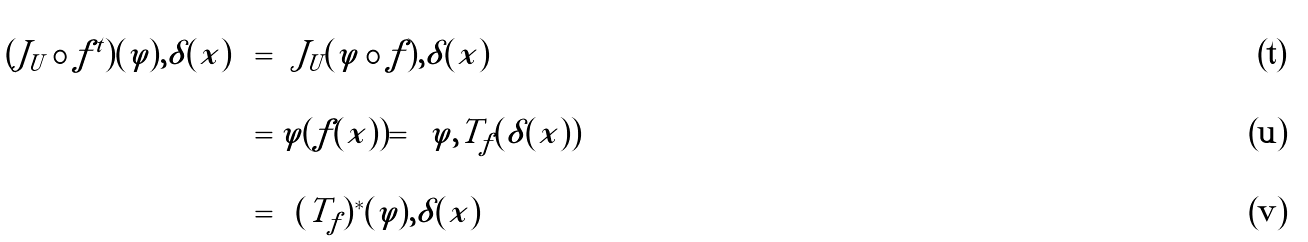Convert formula to latex. <formula><loc_0><loc_0><loc_500><loc_500>\left \langle ( J _ { U } \circ f ^ { t } ) ( \varphi ) , \delta ( x ) \right \rangle & = \left \langle J _ { U } ( \varphi \circ f ) , \delta ( x ) \right \rangle \\ & = \varphi ( f ( x ) ) = \left \langle \varphi , T _ { f } ( \delta ( x ) ) \right \rangle \\ & = \left \langle ( T _ { f } ) ^ { * } ( \varphi ) , \delta ( x ) \right \rangle</formula> 